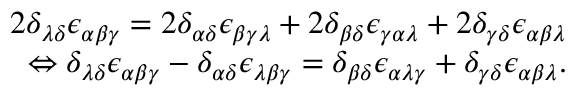<formula> <loc_0><loc_0><loc_500><loc_500>\begin{array} { r } { 2 \delta _ { \lambda \delta } \epsilon _ { \alpha \beta \gamma } = 2 \delta _ { \alpha \delta } \epsilon _ { \beta \gamma \lambda } + 2 \delta _ { \beta \delta } \epsilon _ { \gamma \alpha \lambda } + 2 \delta _ { \gamma \delta } \epsilon _ { \alpha \beta \lambda } } \\ { \Leftrightarrow \delta _ { \lambda \delta } \epsilon _ { \alpha \beta \gamma } - \delta _ { \alpha \delta } \epsilon _ { \lambda \beta \gamma } = \delta _ { \beta \delta } \epsilon _ { \alpha \lambda \gamma } + \delta _ { \gamma \delta } \epsilon _ { \alpha \beta \lambda } . } \end{array}</formula> 